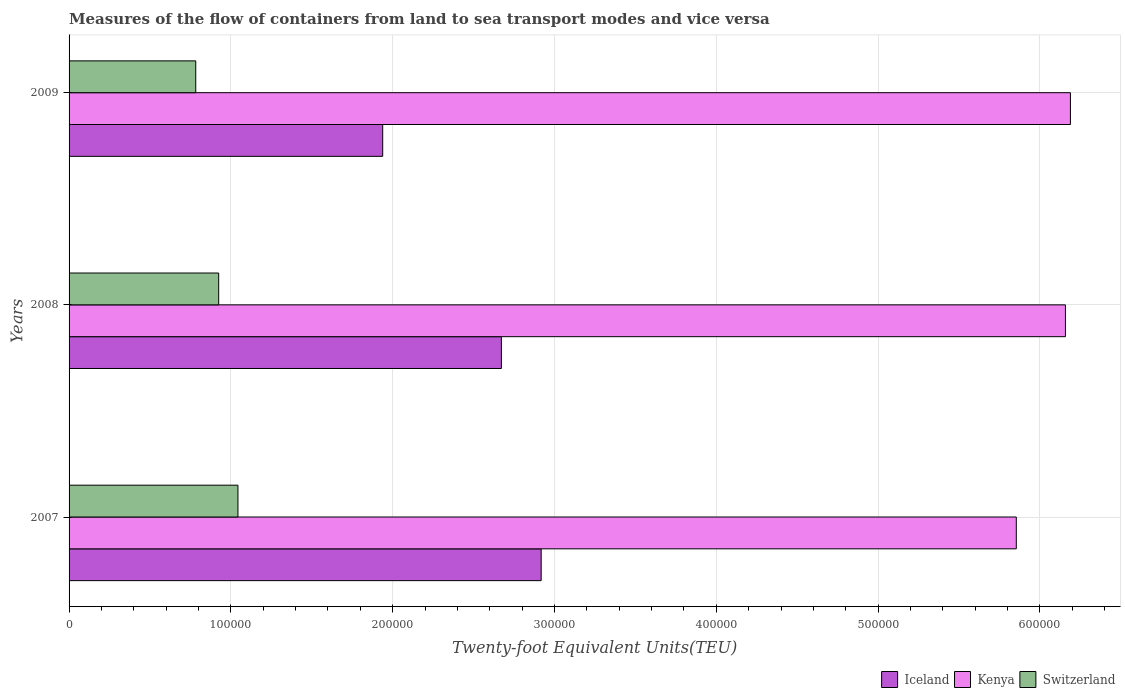Are the number of bars per tick equal to the number of legend labels?
Make the answer very short. Yes. How many bars are there on the 1st tick from the bottom?
Keep it short and to the point. 3. What is the label of the 1st group of bars from the top?
Ensure brevity in your answer.  2009. What is the container port traffic in Kenya in 2007?
Ensure brevity in your answer.  5.85e+05. Across all years, what is the maximum container port traffic in Iceland?
Provide a short and direct response. 2.92e+05. Across all years, what is the minimum container port traffic in Kenya?
Your response must be concise. 5.85e+05. What is the total container port traffic in Iceland in the graph?
Make the answer very short. 7.53e+05. What is the difference between the container port traffic in Kenya in 2007 and that in 2008?
Provide a succinct answer. -3.04e+04. What is the difference between the container port traffic in Iceland in 2009 and the container port traffic in Switzerland in 2008?
Provide a short and direct response. 1.01e+05. What is the average container port traffic in Iceland per year?
Your response must be concise. 2.51e+05. In the year 2009, what is the difference between the container port traffic in Iceland and container port traffic in Switzerland?
Keep it short and to the point. 1.16e+05. What is the ratio of the container port traffic in Switzerland in 2007 to that in 2009?
Keep it short and to the point. 1.33. Is the difference between the container port traffic in Iceland in 2007 and 2008 greater than the difference between the container port traffic in Switzerland in 2007 and 2008?
Your response must be concise. Yes. What is the difference between the highest and the second highest container port traffic in Iceland?
Your answer should be very brief. 2.46e+04. What is the difference between the highest and the lowest container port traffic in Kenya?
Provide a succinct answer. 3.34e+04. Is the sum of the container port traffic in Kenya in 2007 and 2009 greater than the maximum container port traffic in Iceland across all years?
Keep it short and to the point. Yes. What does the 1st bar from the top in 2009 represents?
Your response must be concise. Switzerland. What does the 2nd bar from the bottom in 2008 represents?
Offer a terse response. Kenya. How many years are there in the graph?
Offer a very short reply. 3. Does the graph contain any zero values?
Give a very brief answer. No. Where does the legend appear in the graph?
Your answer should be very brief. Bottom right. How are the legend labels stacked?
Ensure brevity in your answer.  Horizontal. What is the title of the graph?
Provide a succinct answer. Measures of the flow of containers from land to sea transport modes and vice versa. What is the label or title of the X-axis?
Provide a short and direct response. Twenty-foot Equivalent Units(TEU). What is the Twenty-foot Equivalent Units(TEU) of Iceland in 2007?
Offer a terse response. 2.92e+05. What is the Twenty-foot Equivalent Units(TEU) of Kenya in 2007?
Keep it short and to the point. 5.85e+05. What is the Twenty-foot Equivalent Units(TEU) of Switzerland in 2007?
Offer a very short reply. 1.04e+05. What is the Twenty-foot Equivalent Units(TEU) in Iceland in 2008?
Make the answer very short. 2.67e+05. What is the Twenty-foot Equivalent Units(TEU) of Kenya in 2008?
Ensure brevity in your answer.  6.16e+05. What is the Twenty-foot Equivalent Units(TEU) of Switzerland in 2008?
Give a very brief answer. 9.25e+04. What is the Twenty-foot Equivalent Units(TEU) in Iceland in 2009?
Keep it short and to the point. 1.94e+05. What is the Twenty-foot Equivalent Units(TEU) in Kenya in 2009?
Your answer should be very brief. 6.19e+05. What is the Twenty-foot Equivalent Units(TEU) in Switzerland in 2009?
Give a very brief answer. 7.83e+04. Across all years, what is the maximum Twenty-foot Equivalent Units(TEU) in Iceland?
Your answer should be compact. 2.92e+05. Across all years, what is the maximum Twenty-foot Equivalent Units(TEU) of Kenya?
Your answer should be compact. 6.19e+05. Across all years, what is the maximum Twenty-foot Equivalent Units(TEU) in Switzerland?
Provide a short and direct response. 1.04e+05. Across all years, what is the minimum Twenty-foot Equivalent Units(TEU) in Iceland?
Make the answer very short. 1.94e+05. Across all years, what is the minimum Twenty-foot Equivalent Units(TEU) in Kenya?
Offer a very short reply. 5.85e+05. Across all years, what is the minimum Twenty-foot Equivalent Units(TEU) in Switzerland?
Keep it short and to the point. 7.83e+04. What is the total Twenty-foot Equivalent Units(TEU) in Iceland in the graph?
Make the answer very short. 7.53e+05. What is the total Twenty-foot Equivalent Units(TEU) in Kenya in the graph?
Your answer should be compact. 1.82e+06. What is the total Twenty-foot Equivalent Units(TEU) in Switzerland in the graph?
Give a very brief answer. 2.75e+05. What is the difference between the Twenty-foot Equivalent Units(TEU) in Iceland in 2007 and that in 2008?
Provide a short and direct response. 2.46e+04. What is the difference between the Twenty-foot Equivalent Units(TEU) of Kenya in 2007 and that in 2008?
Keep it short and to the point. -3.04e+04. What is the difference between the Twenty-foot Equivalent Units(TEU) of Switzerland in 2007 and that in 2008?
Give a very brief answer. 1.19e+04. What is the difference between the Twenty-foot Equivalent Units(TEU) of Iceland in 2007 and that in 2009?
Ensure brevity in your answer.  9.79e+04. What is the difference between the Twenty-foot Equivalent Units(TEU) in Kenya in 2007 and that in 2009?
Make the answer very short. -3.34e+04. What is the difference between the Twenty-foot Equivalent Units(TEU) in Switzerland in 2007 and that in 2009?
Your answer should be very brief. 2.61e+04. What is the difference between the Twenty-foot Equivalent Units(TEU) in Iceland in 2008 and that in 2009?
Your response must be concise. 7.33e+04. What is the difference between the Twenty-foot Equivalent Units(TEU) in Kenya in 2008 and that in 2009?
Keep it short and to the point. -3083. What is the difference between the Twenty-foot Equivalent Units(TEU) in Switzerland in 2008 and that in 2009?
Your answer should be very brief. 1.42e+04. What is the difference between the Twenty-foot Equivalent Units(TEU) of Iceland in 2007 and the Twenty-foot Equivalent Units(TEU) of Kenya in 2008?
Offer a terse response. -3.24e+05. What is the difference between the Twenty-foot Equivalent Units(TEU) in Iceland in 2007 and the Twenty-foot Equivalent Units(TEU) in Switzerland in 2008?
Give a very brief answer. 1.99e+05. What is the difference between the Twenty-foot Equivalent Units(TEU) of Kenya in 2007 and the Twenty-foot Equivalent Units(TEU) of Switzerland in 2008?
Give a very brief answer. 4.93e+05. What is the difference between the Twenty-foot Equivalent Units(TEU) of Iceland in 2007 and the Twenty-foot Equivalent Units(TEU) of Kenya in 2009?
Give a very brief answer. -3.27e+05. What is the difference between the Twenty-foot Equivalent Units(TEU) of Iceland in 2007 and the Twenty-foot Equivalent Units(TEU) of Switzerland in 2009?
Provide a succinct answer. 2.13e+05. What is the difference between the Twenty-foot Equivalent Units(TEU) in Kenya in 2007 and the Twenty-foot Equivalent Units(TEU) in Switzerland in 2009?
Offer a terse response. 5.07e+05. What is the difference between the Twenty-foot Equivalent Units(TEU) of Iceland in 2008 and the Twenty-foot Equivalent Units(TEU) of Kenya in 2009?
Provide a short and direct response. -3.52e+05. What is the difference between the Twenty-foot Equivalent Units(TEU) in Iceland in 2008 and the Twenty-foot Equivalent Units(TEU) in Switzerland in 2009?
Keep it short and to the point. 1.89e+05. What is the difference between the Twenty-foot Equivalent Units(TEU) in Kenya in 2008 and the Twenty-foot Equivalent Units(TEU) in Switzerland in 2009?
Provide a succinct answer. 5.37e+05. What is the average Twenty-foot Equivalent Units(TEU) of Iceland per year?
Provide a succinct answer. 2.51e+05. What is the average Twenty-foot Equivalent Units(TEU) in Kenya per year?
Ensure brevity in your answer.  6.07e+05. What is the average Twenty-foot Equivalent Units(TEU) of Switzerland per year?
Ensure brevity in your answer.  9.17e+04. In the year 2007, what is the difference between the Twenty-foot Equivalent Units(TEU) in Iceland and Twenty-foot Equivalent Units(TEU) in Kenya?
Provide a succinct answer. -2.94e+05. In the year 2007, what is the difference between the Twenty-foot Equivalent Units(TEU) of Iceland and Twenty-foot Equivalent Units(TEU) of Switzerland?
Give a very brief answer. 1.87e+05. In the year 2007, what is the difference between the Twenty-foot Equivalent Units(TEU) in Kenya and Twenty-foot Equivalent Units(TEU) in Switzerland?
Give a very brief answer. 4.81e+05. In the year 2008, what is the difference between the Twenty-foot Equivalent Units(TEU) of Iceland and Twenty-foot Equivalent Units(TEU) of Kenya?
Offer a very short reply. -3.49e+05. In the year 2008, what is the difference between the Twenty-foot Equivalent Units(TEU) of Iceland and Twenty-foot Equivalent Units(TEU) of Switzerland?
Ensure brevity in your answer.  1.75e+05. In the year 2008, what is the difference between the Twenty-foot Equivalent Units(TEU) in Kenya and Twenty-foot Equivalent Units(TEU) in Switzerland?
Your answer should be compact. 5.23e+05. In the year 2009, what is the difference between the Twenty-foot Equivalent Units(TEU) in Iceland and Twenty-foot Equivalent Units(TEU) in Kenya?
Your answer should be very brief. -4.25e+05. In the year 2009, what is the difference between the Twenty-foot Equivalent Units(TEU) of Iceland and Twenty-foot Equivalent Units(TEU) of Switzerland?
Make the answer very short. 1.16e+05. In the year 2009, what is the difference between the Twenty-foot Equivalent Units(TEU) of Kenya and Twenty-foot Equivalent Units(TEU) of Switzerland?
Keep it short and to the point. 5.41e+05. What is the ratio of the Twenty-foot Equivalent Units(TEU) of Iceland in 2007 to that in 2008?
Provide a succinct answer. 1.09. What is the ratio of the Twenty-foot Equivalent Units(TEU) of Kenya in 2007 to that in 2008?
Offer a very short reply. 0.95. What is the ratio of the Twenty-foot Equivalent Units(TEU) of Switzerland in 2007 to that in 2008?
Provide a succinct answer. 1.13. What is the ratio of the Twenty-foot Equivalent Units(TEU) in Iceland in 2007 to that in 2009?
Offer a very short reply. 1.51. What is the ratio of the Twenty-foot Equivalent Units(TEU) of Kenya in 2007 to that in 2009?
Keep it short and to the point. 0.95. What is the ratio of the Twenty-foot Equivalent Units(TEU) of Switzerland in 2007 to that in 2009?
Provide a succinct answer. 1.33. What is the ratio of the Twenty-foot Equivalent Units(TEU) in Iceland in 2008 to that in 2009?
Make the answer very short. 1.38. What is the ratio of the Twenty-foot Equivalent Units(TEU) of Switzerland in 2008 to that in 2009?
Your answer should be compact. 1.18. What is the difference between the highest and the second highest Twenty-foot Equivalent Units(TEU) in Iceland?
Ensure brevity in your answer.  2.46e+04. What is the difference between the highest and the second highest Twenty-foot Equivalent Units(TEU) in Kenya?
Offer a very short reply. 3083. What is the difference between the highest and the second highest Twenty-foot Equivalent Units(TEU) in Switzerland?
Provide a succinct answer. 1.19e+04. What is the difference between the highest and the lowest Twenty-foot Equivalent Units(TEU) in Iceland?
Offer a very short reply. 9.79e+04. What is the difference between the highest and the lowest Twenty-foot Equivalent Units(TEU) in Kenya?
Give a very brief answer. 3.34e+04. What is the difference between the highest and the lowest Twenty-foot Equivalent Units(TEU) in Switzerland?
Offer a very short reply. 2.61e+04. 